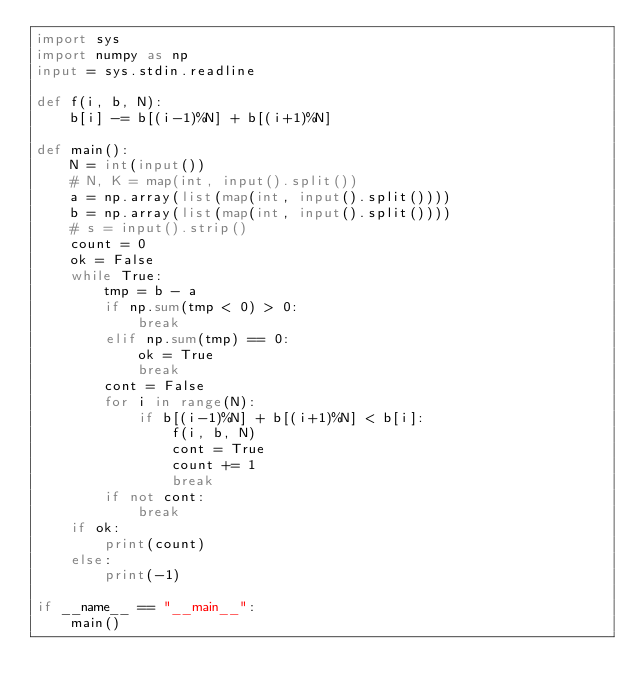<code> <loc_0><loc_0><loc_500><loc_500><_Python_>import sys
import numpy as np
input = sys.stdin.readline

def f(i, b, N):
    b[i] -= b[(i-1)%N] + b[(i+1)%N]

def main():
    N = int(input())
    # N, K = map(int, input().split())
    a = np.array(list(map(int, input().split())))
    b = np.array(list(map(int, input().split())))
    # s = input().strip()
    count = 0
    ok = False
    while True:
        tmp = b - a
        if np.sum(tmp < 0) > 0:
            break
        elif np.sum(tmp) == 0:
            ok = True
            break
        cont = False
        for i in range(N):
            if b[(i-1)%N] + b[(i+1)%N] < b[i]:
                f(i, b, N)
                cont = True
                count += 1
                break
        if not cont:
            break
    if ok:
        print(count)
    else:
        print(-1)

if __name__ == "__main__":
    main()</code> 